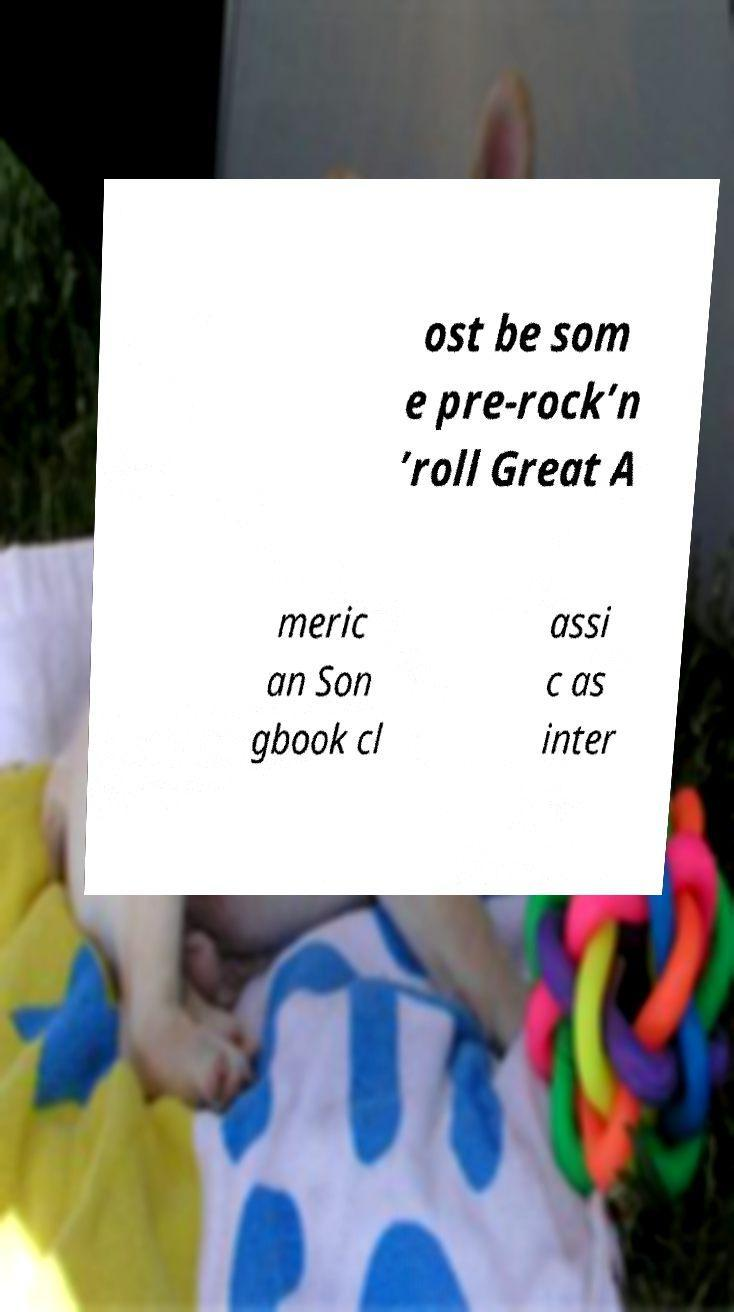Could you extract and type out the text from this image? ost be som e pre-rock’n ’roll Great A meric an Son gbook cl assi c as inter 